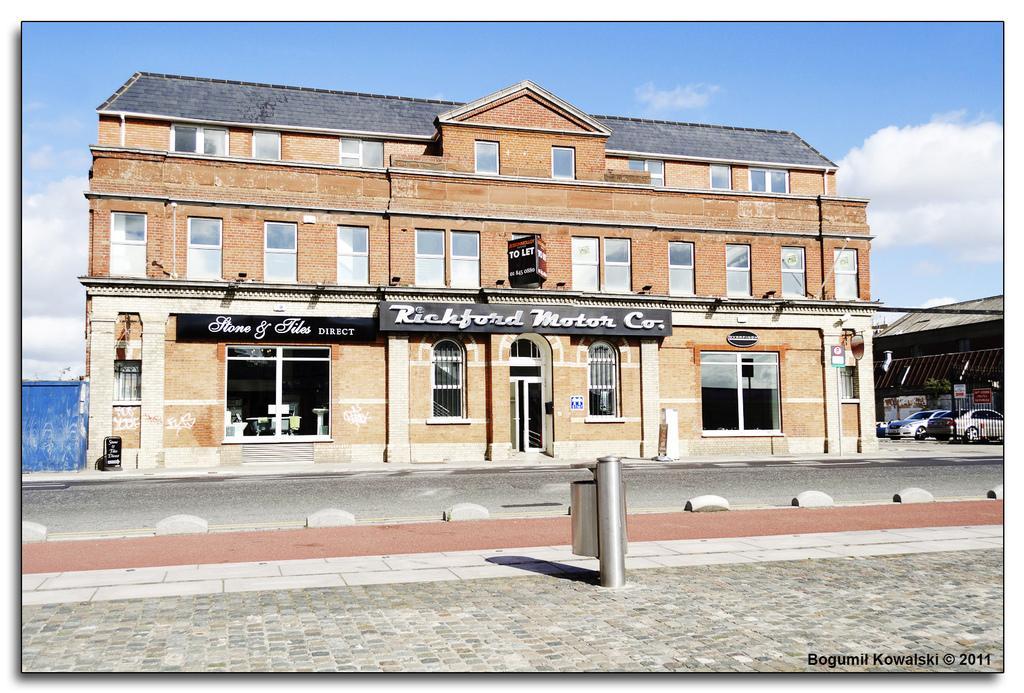Could you give a brief overview of what you see in this image? This image is clicked on the road. Beside the road there is a walkway. On the other side of the road there are buildings. There are boards with text on the building. To the right there are cars parked under the shed. At the top there is the sky. In the bottom right there is text on the image. 